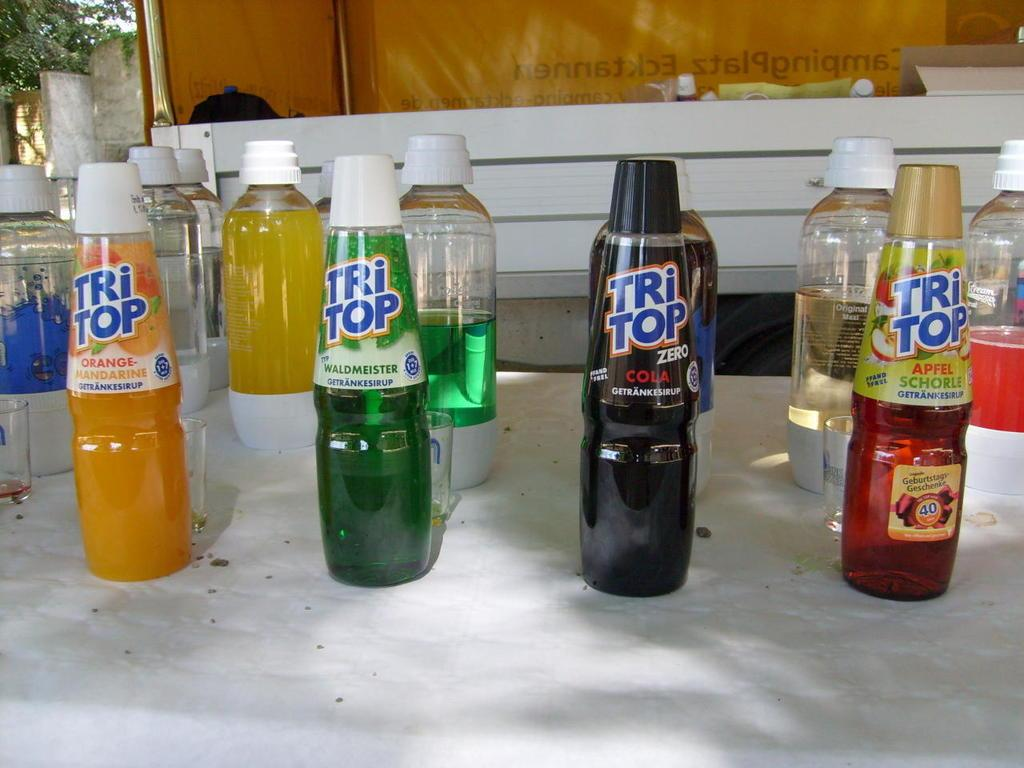<image>
Relay a brief, clear account of the picture shown. Bottles that are of the brand Tri Top are lined up on a table. 